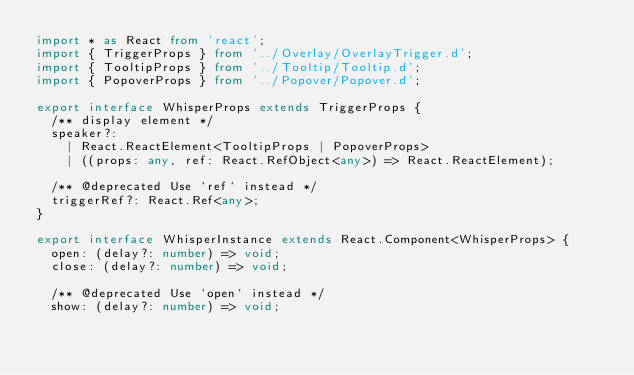Convert code to text. <code><loc_0><loc_0><loc_500><loc_500><_TypeScript_>import * as React from 'react';
import { TriggerProps } from '../Overlay/OverlayTrigger.d';
import { TooltipProps } from '../Tooltip/Tooltip.d';
import { PopoverProps } from '../Popover/Popover.d';

export interface WhisperProps extends TriggerProps {
  /** display element */
  speaker?:
    | React.ReactElement<TooltipProps | PopoverProps>
    | ((props: any, ref: React.RefObject<any>) => React.ReactElement);

  /** @deprecated Use `ref` instead */
  triggerRef?: React.Ref<any>;
}

export interface WhisperInstance extends React.Component<WhisperProps> {
  open: (delay?: number) => void;
  close: (delay?: number) => void;

  /** @deprecated Use `open` instead */
  show: (delay?: number) => void;</code> 